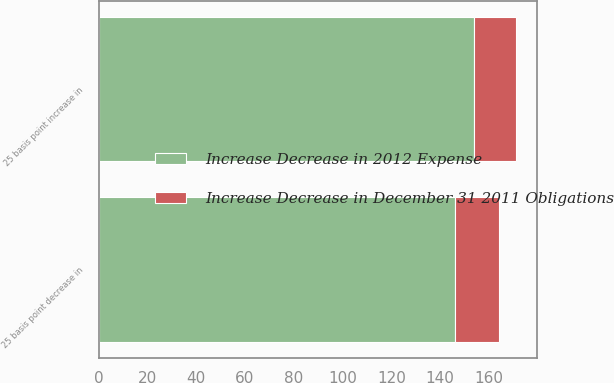<chart> <loc_0><loc_0><loc_500><loc_500><stacked_bar_chart><ecel><fcel>25 basis point decrease in<fcel>25 basis point increase in<nl><fcel>Increase Decrease in December 31 2011 Obligations<fcel>18<fcel>17<nl><fcel>Increase Decrease in 2012 Expense<fcel>146<fcel>154<nl></chart> 